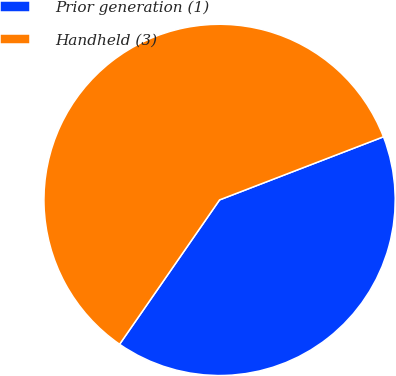Convert chart to OTSL. <chart><loc_0><loc_0><loc_500><loc_500><pie_chart><fcel>Prior generation (1)<fcel>Handheld (3)<nl><fcel>40.49%<fcel>59.51%<nl></chart> 